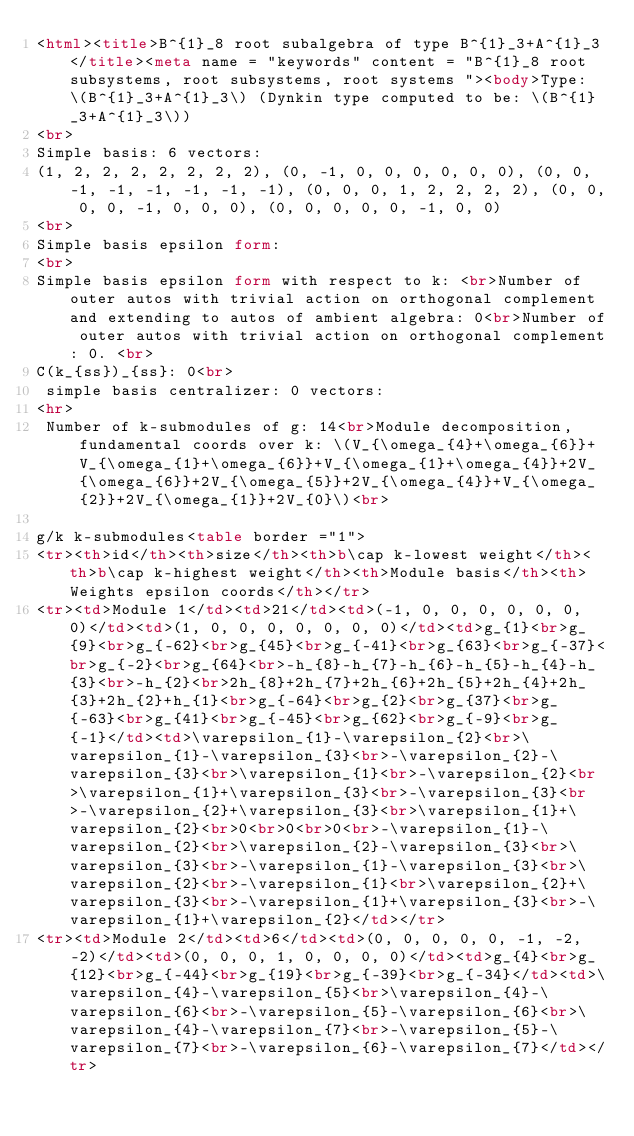Convert code to text. <code><loc_0><loc_0><loc_500><loc_500><_HTML_><html><title>B^{1}_8 root subalgebra of type B^{1}_3+A^{1}_3</title><meta name = "keywords" content = "B^{1}_8 root subsystems, root subsystems, root systems "><body>Type: \(B^{1}_3+A^{1}_3\) (Dynkin type computed to be: \(B^{1}_3+A^{1}_3\))
<br>
Simple basis: 6 vectors: 
(1, 2, 2, 2, 2, 2, 2, 2), (0, -1, 0, 0, 0, 0, 0, 0), (0, 0, -1, -1, -1, -1, -1, -1), (0, 0, 0, 1, 2, 2, 2, 2), (0, 0, 0, 0, -1, 0, 0, 0), (0, 0, 0, 0, 0, -1, 0, 0)
<br>
Simple basis epsilon form: 
<br>
Simple basis epsilon form with respect to k: <br>Number of outer autos with trivial action on orthogonal complement and extending to autos of ambient algebra: 0<br>Number of outer autos with trivial action on orthogonal complement: 0. <br>
C(k_{ss})_{ss}: 0<br>
 simple basis centralizer: 0 vectors: 
<hr>
 Number of k-submodules of g: 14<br>Module decomposition, fundamental coords over k: \(V_{\omega_{4}+\omega_{6}}+V_{\omega_{1}+\omega_{6}}+V_{\omega_{1}+\omega_{4}}+2V_{\omega_{6}}+2V_{\omega_{5}}+2V_{\omega_{4}}+V_{\omega_{2}}+2V_{\omega_{1}}+2V_{0}\)<br>

g/k k-submodules<table border ="1">
<tr><th>id</th><th>size</th><th>b\cap k-lowest weight</th><th>b\cap k-highest weight</th><th>Module basis</th><th>Weights epsilon coords</th></tr>
<tr><td>Module 1</td><td>21</td><td>(-1, 0, 0, 0, 0, 0, 0, 0)</td><td>(1, 0, 0, 0, 0, 0, 0, 0)</td><td>g_{1}<br>g_{9}<br>g_{-62}<br>g_{45}<br>g_{-41}<br>g_{63}<br>g_{-37}<br>g_{-2}<br>g_{64}<br>-h_{8}-h_{7}-h_{6}-h_{5}-h_{4}-h_{3}<br>-h_{2}<br>2h_{8}+2h_{7}+2h_{6}+2h_{5}+2h_{4}+2h_{3}+2h_{2}+h_{1}<br>g_{-64}<br>g_{2}<br>g_{37}<br>g_{-63}<br>g_{41}<br>g_{-45}<br>g_{62}<br>g_{-9}<br>g_{-1}</td><td>\varepsilon_{1}-\varepsilon_{2}<br>\varepsilon_{1}-\varepsilon_{3}<br>-\varepsilon_{2}-\varepsilon_{3}<br>\varepsilon_{1}<br>-\varepsilon_{2}<br>\varepsilon_{1}+\varepsilon_{3}<br>-\varepsilon_{3}<br>-\varepsilon_{2}+\varepsilon_{3}<br>\varepsilon_{1}+\varepsilon_{2}<br>0<br>0<br>0<br>-\varepsilon_{1}-\varepsilon_{2}<br>\varepsilon_{2}-\varepsilon_{3}<br>\varepsilon_{3}<br>-\varepsilon_{1}-\varepsilon_{3}<br>\varepsilon_{2}<br>-\varepsilon_{1}<br>\varepsilon_{2}+\varepsilon_{3}<br>-\varepsilon_{1}+\varepsilon_{3}<br>-\varepsilon_{1}+\varepsilon_{2}</td></tr>
<tr><td>Module 2</td><td>6</td><td>(0, 0, 0, 0, 0, -1, -2, -2)</td><td>(0, 0, 0, 1, 0, 0, 0, 0)</td><td>g_{4}<br>g_{12}<br>g_{-44}<br>g_{19}<br>g_{-39}<br>g_{-34}</td><td>\varepsilon_{4}-\varepsilon_{5}<br>\varepsilon_{4}-\varepsilon_{6}<br>-\varepsilon_{5}-\varepsilon_{6}<br>\varepsilon_{4}-\varepsilon_{7}<br>-\varepsilon_{5}-\varepsilon_{7}<br>-\varepsilon_{6}-\varepsilon_{7}</td></tr></code> 